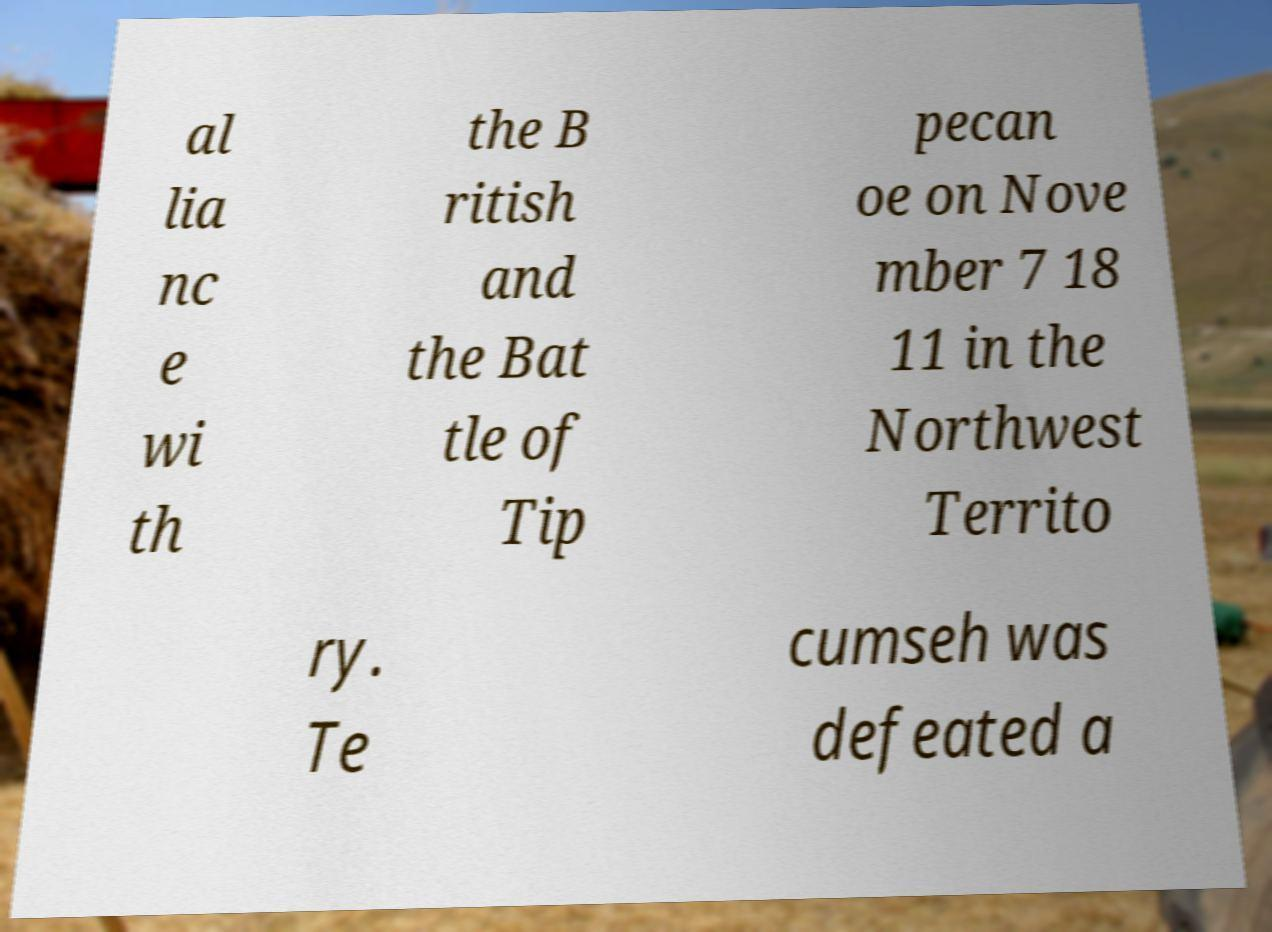Can you read and provide the text displayed in the image?This photo seems to have some interesting text. Can you extract and type it out for me? al lia nc e wi th the B ritish and the Bat tle of Tip pecan oe on Nove mber 7 18 11 in the Northwest Territo ry. Te cumseh was defeated a 